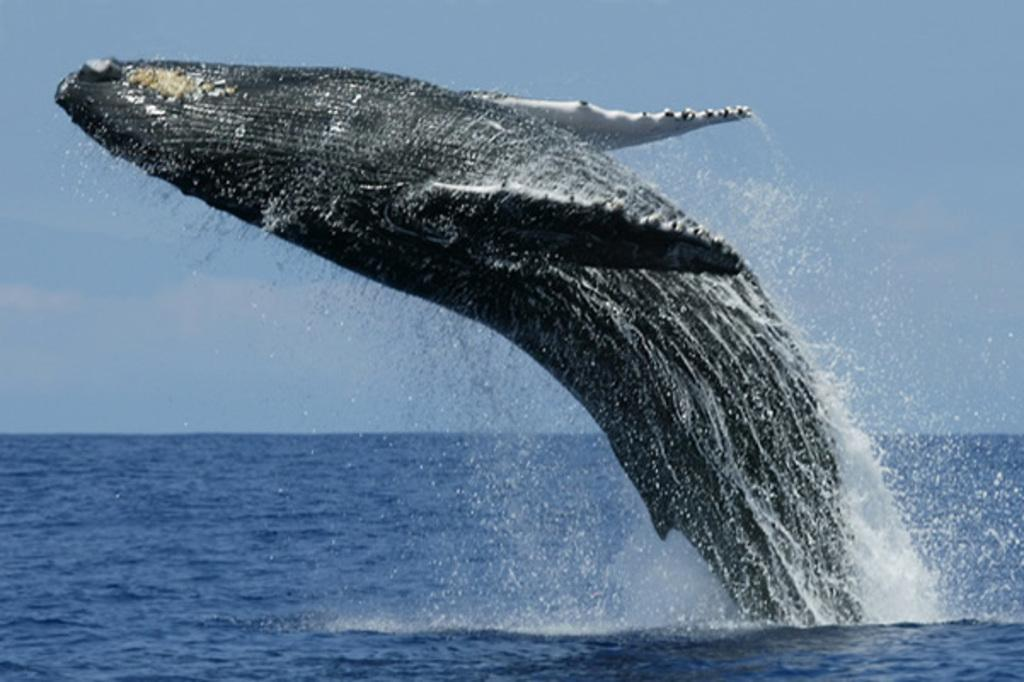What animal is the main subject of the image? There is a whale in the image. What is the whale doing in the image? The whale is swimming out from the water surface. What town is the whale's sister visiting in the image? There is no town or sister mentioned in the image; it only features a whale swimming out from the water surface. 